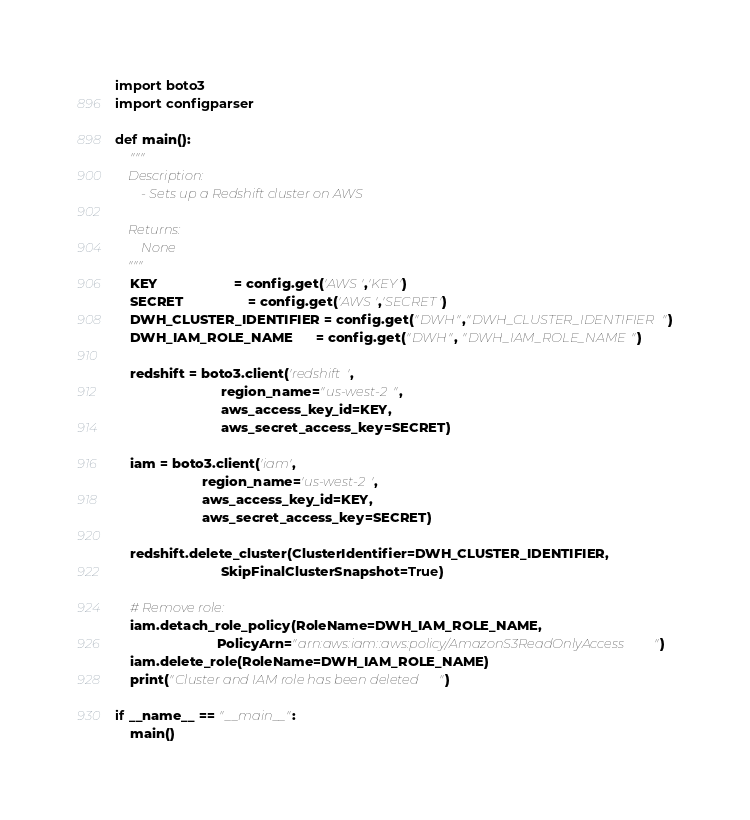Convert code to text. <code><loc_0><loc_0><loc_500><loc_500><_Python_>import boto3
import configparser

def main():
    """
    Description:
        - Sets up a Redshift cluster on AWS
    
    Returns:
        None
    """
    KEY                    = config.get('AWS','KEY')
    SECRET                 = config.get('AWS','SECRET')
    DWH_CLUSTER_IDENTIFIER = config.get("DWH","DWH_CLUSTER_IDENTIFIER")
    DWH_IAM_ROLE_NAME      = config.get("DWH", "DWH_IAM_ROLE_NAME")

    redshift = boto3.client('redshift',
                            region_name="us-west-2",
                            aws_access_key_id=KEY,
                            aws_secret_access_key=SECRET)

    iam = boto3.client('iam',
                       region_name='us-west-2',
                       aws_access_key_id=KEY,
                       aws_secret_access_key=SECRET)

    redshift.delete_cluster(ClusterIdentifier=DWH_CLUSTER_IDENTIFIER,  
                            SkipFinalClusterSnapshot=True)
    
    # Remove role:
    iam.detach_role_policy(RoleName=DWH_IAM_ROLE_NAME, 
                           PolicyArn="arn:aws:iam::aws:policy/AmazonS3ReadOnlyAccess")
    iam.delete_role(RoleName=DWH_IAM_ROLE_NAME)
    print("Cluster and IAM role has been deleted")

if __name__ == "__main__":
    main()</code> 